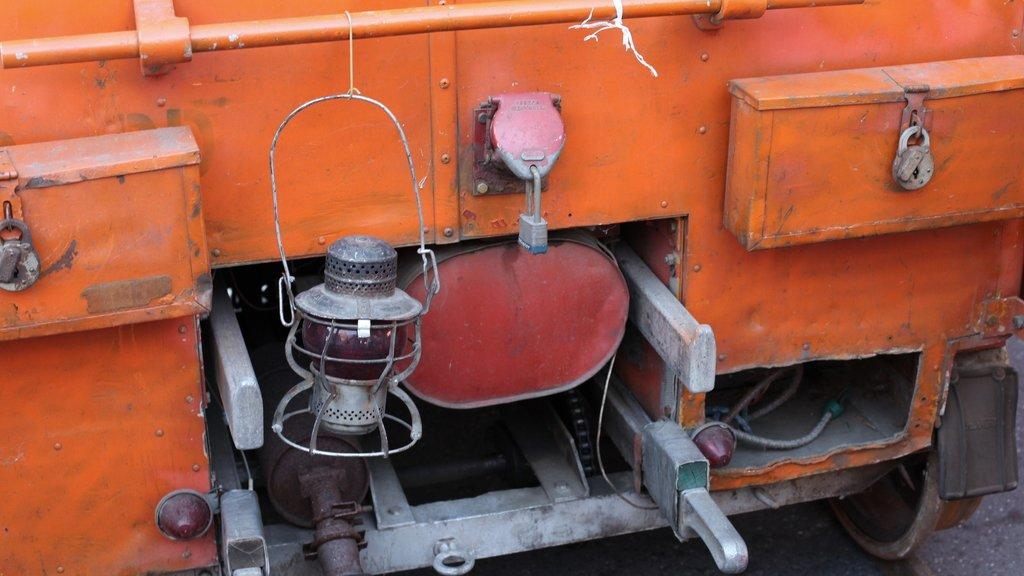What type of objects can be seen in the image? There are boxes, a lantern lamp, locks, and a rod in the image. Can you describe the lantern lamp in the image? The lantern lamp is a source of light in the image. What might be used to secure or protect the boxes in the image? The locks in the image might be used to secure or protect the boxes. What is the purpose of the rod in the image? The purpose of the rod in the image is not specified, but it could be used for support or hanging objects. What type of market is depicted in the image? There is no market present in the image; it only contains boxes, a lantern lamp, locks, and a rod. Can you tell me how many brains are visible in the image? There are no brains present in the image; it only contains boxes, a lantern lamp, locks, and a rod. 